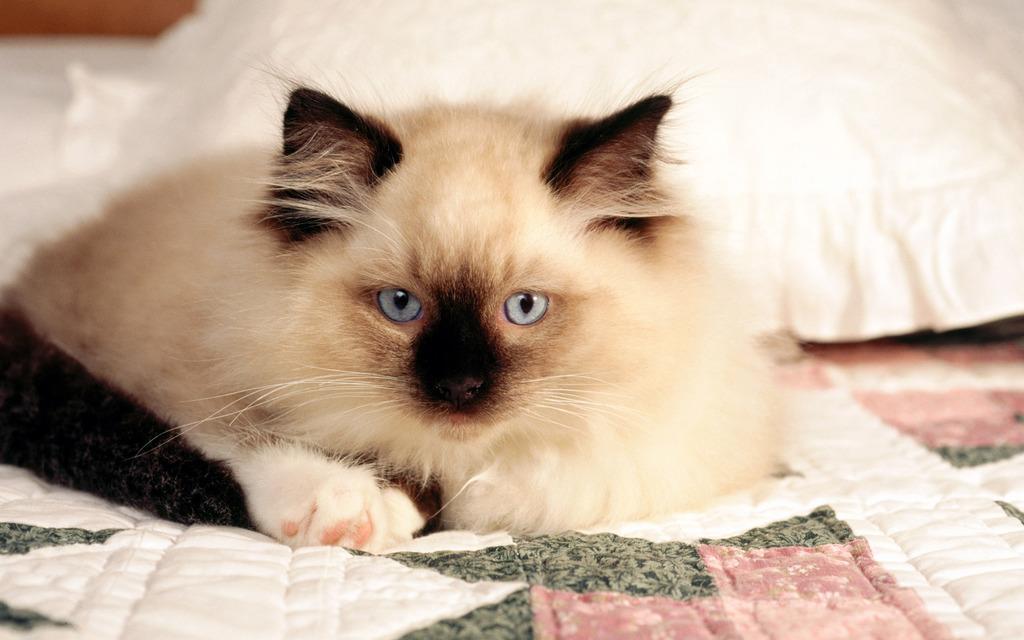Describe this image in one or two sentences. In this image a cat is sitting on the bed. Behind it there is a pillow. 